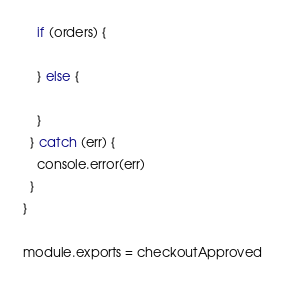Convert code to text. <code><loc_0><loc_0><loc_500><loc_500><_JavaScript_>
    if (orders) {

    } else {

    }
  } catch (err) {
    console.error(err)
  }
}

module.exports = checkoutApproved</code> 